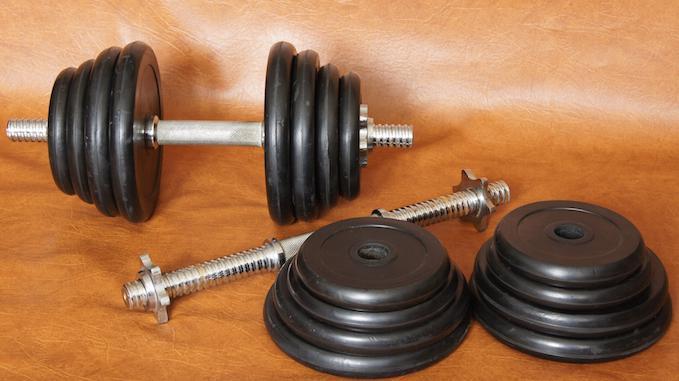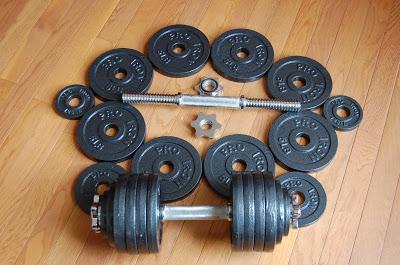The first image is the image on the left, the second image is the image on the right. For the images displayed, is the sentence "One of the images shows an assembled dumbbell with additional plates next to it." factually correct? Answer yes or no. Yes. The first image is the image on the left, the second image is the image on the right. Evaluate the accuracy of this statement regarding the images: "there is a dumb bell laying on a wood floor next to 12 seperate circular flat weights". Is it true? Answer yes or no. Yes. 